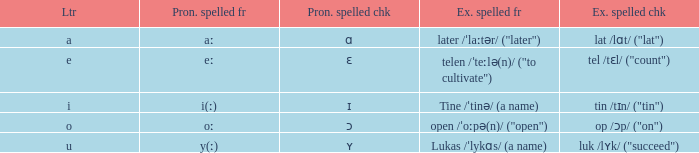What is Pronunciation Spelled Free, when Pronunciation Spelled Checked is "ɑ"? Aː. 